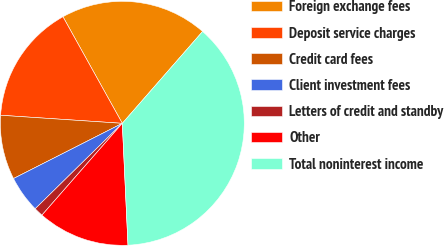<chart> <loc_0><loc_0><loc_500><loc_500><pie_chart><fcel>Foreign exchange fees<fcel>Deposit service charges<fcel>Credit card fees<fcel>Client investment fees<fcel>Letters of credit and standby<fcel>Other<fcel>Total noninterest income<nl><fcel>19.52%<fcel>15.86%<fcel>8.53%<fcel>4.87%<fcel>1.21%<fcel>12.19%<fcel>37.83%<nl></chart> 